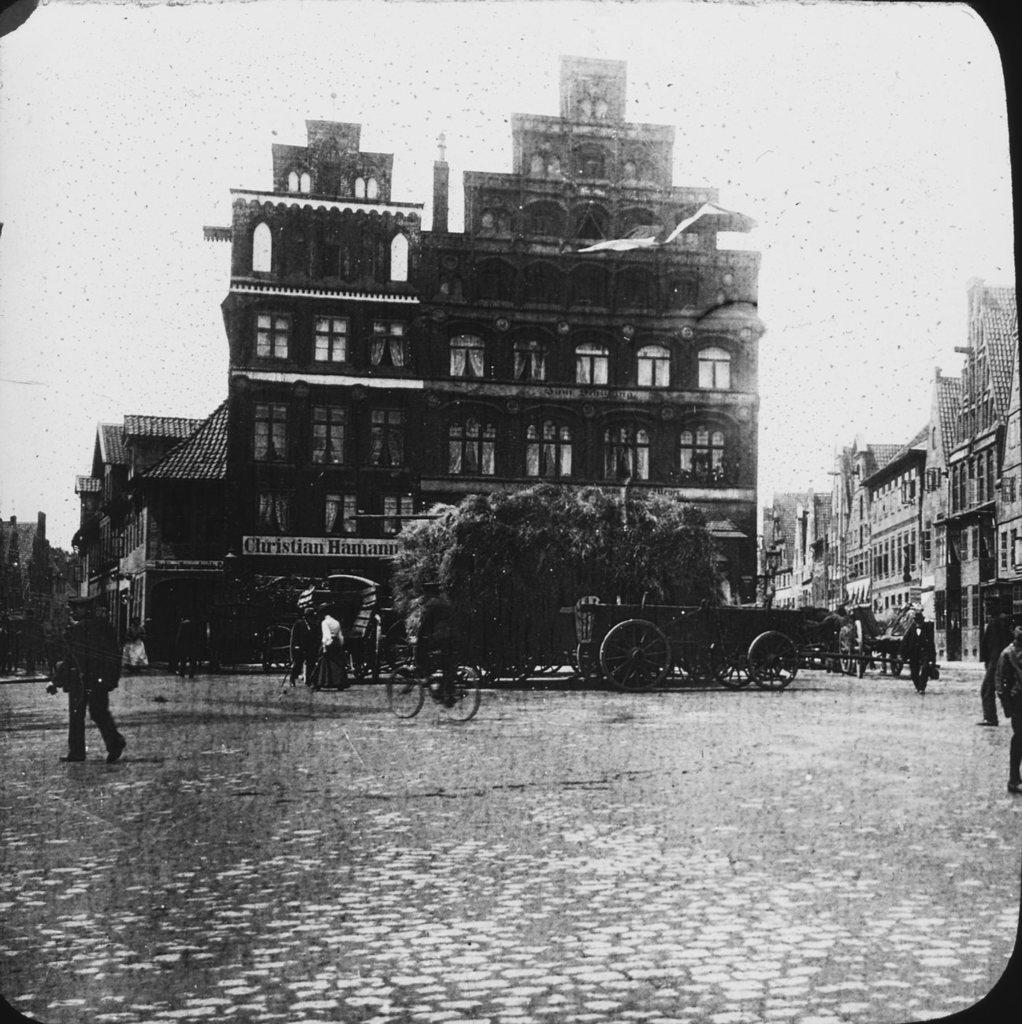In one or two sentences, can you explain what this image depicts? In this picture we can see few buildings, carts and few people, it is a black and white photography. 